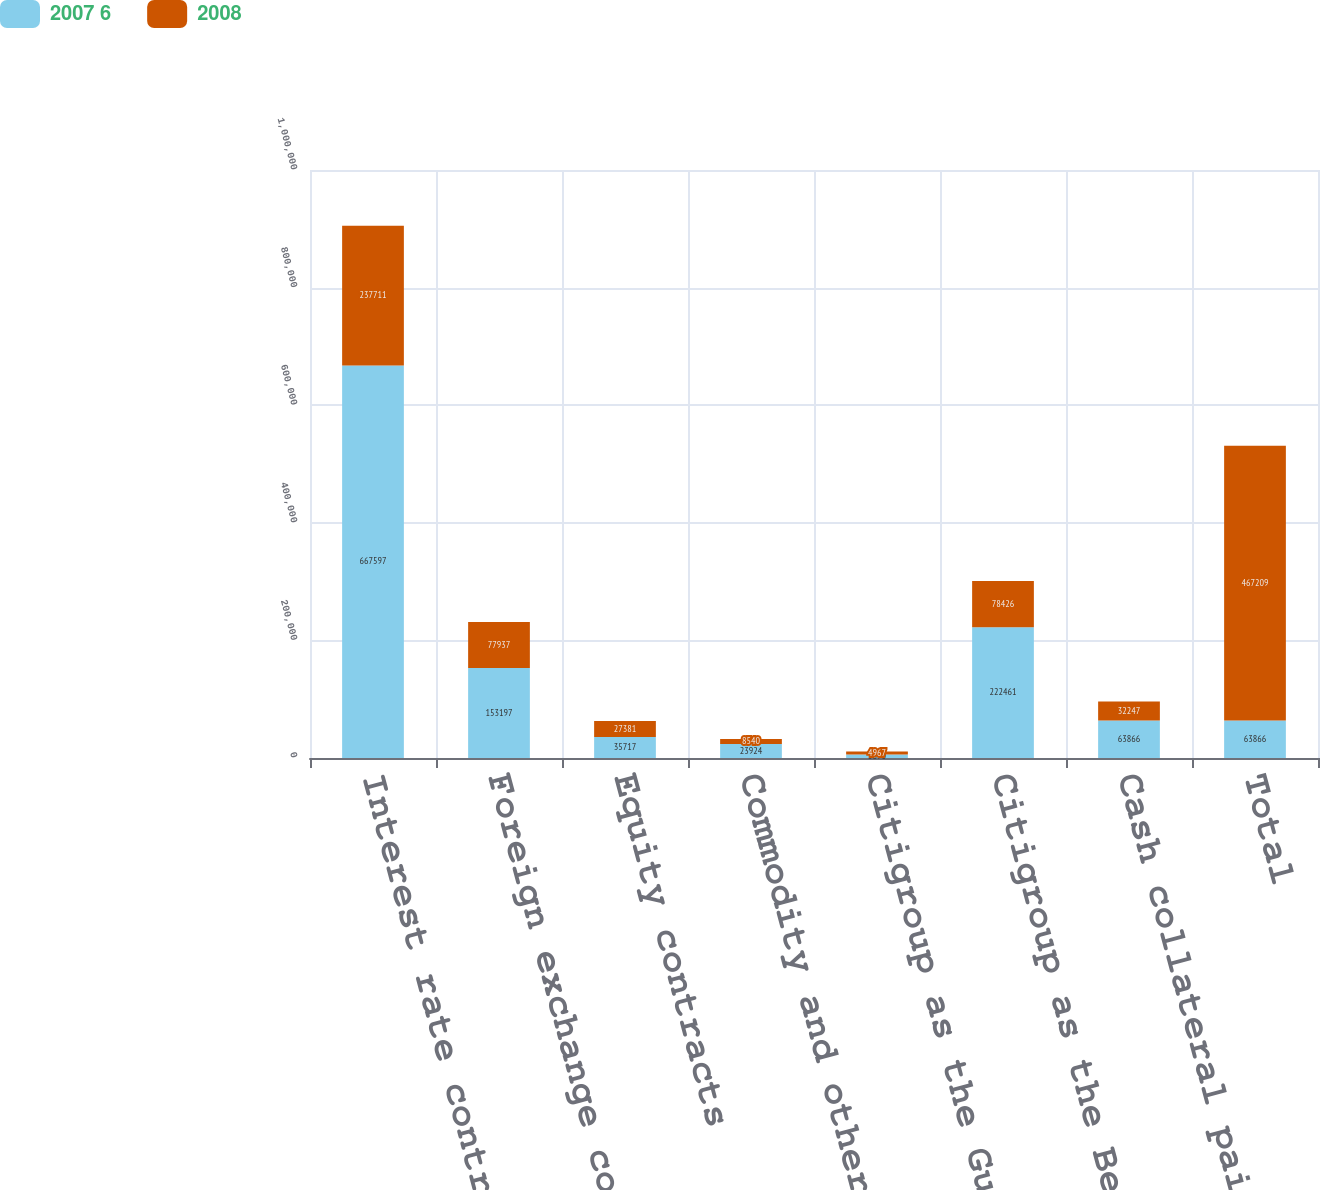Convert chart. <chart><loc_0><loc_0><loc_500><loc_500><stacked_bar_chart><ecel><fcel>Interest rate contracts<fcel>Foreign exchange contracts<fcel>Equity contracts<fcel>Commodity and other contracts<fcel>Citigroup as the Guarantor<fcel>Citigroup as the Beneficiary<fcel>Cash collateral paid/received<fcel>Total<nl><fcel>2007 6<fcel>667597<fcel>153197<fcel>35717<fcel>23924<fcel>5890<fcel>222461<fcel>63866<fcel>63866<nl><fcel>2008<fcel>237711<fcel>77937<fcel>27381<fcel>8540<fcel>4967<fcel>78426<fcel>32247<fcel>467209<nl></chart> 